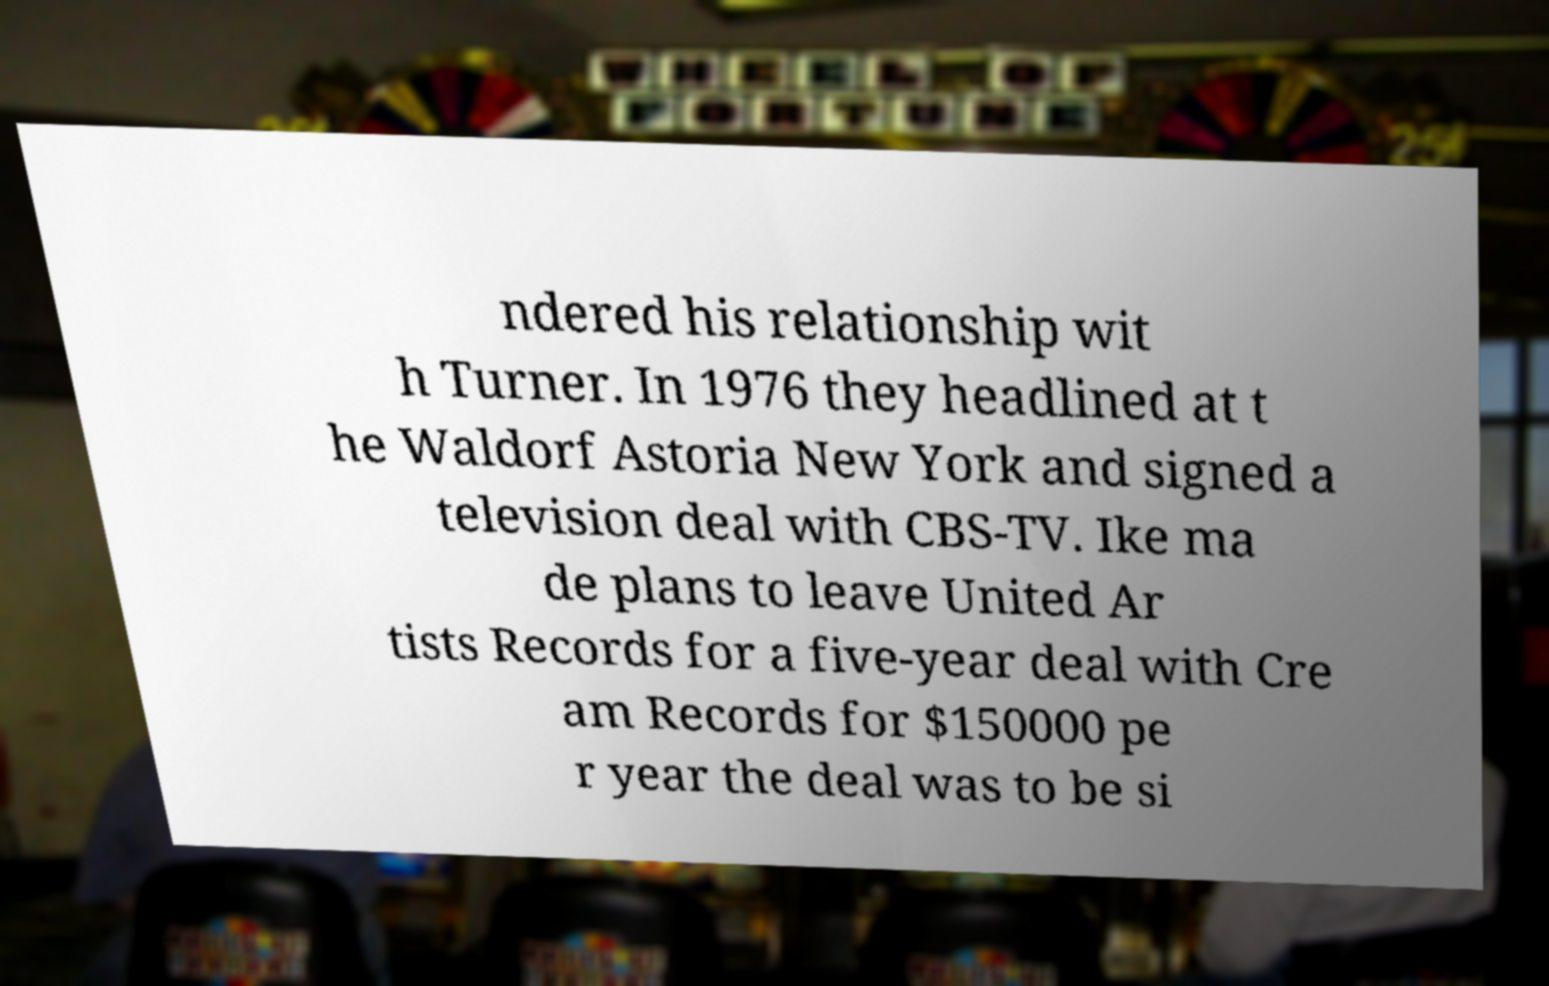What messages or text are displayed in this image? I need them in a readable, typed format. ndered his relationship wit h Turner. In 1976 they headlined at t he Waldorf Astoria New York and signed a television deal with CBS-TV. Ike ma de plans to leave United Ar tists Records for a five-year deal with Cre am Records for $150000 pe r year the deal was to be si 